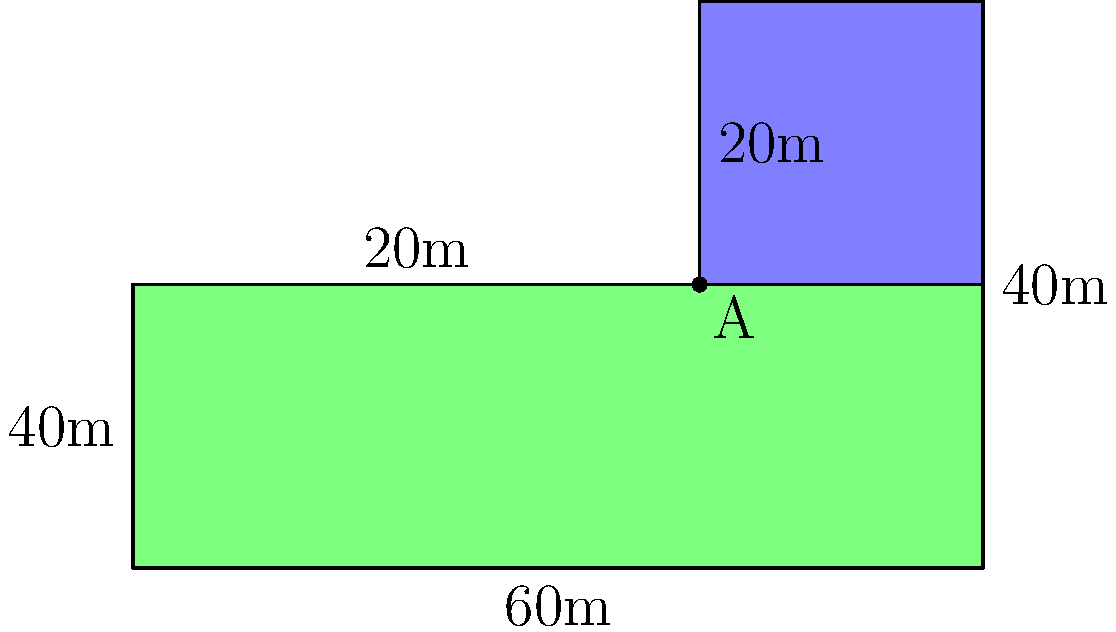A proposed affordable housing complex has an irregular shape as shown in the diagram. The main building (green area) is L-shaped, and there's an additional rectangular community center (blue area) attached to it. Given the dimensions in the diagram, calculate the total area of the complex in square meters. To calculate the total area, we'll break down the complex into simpler shapes and add their areas:

1. L-shaped main building (green area):
   - We can divide this into two rectangles:
     a. Large rectangle: $60\text{ m} \times 20\text{ m} = 1200\text{ m}^2$
     b. Small rectangle: $40\text{ m} \times 20\text{ m} = 800\text{ m}^2$
   - Total area of main building: $1200\text{ m}^2 + 800\text{ m}^2 = 2000\text{ m}^2$

2. Community center (blue area):
   - This is a simple rectangle: $20\text{ m} \times 20\text{ m} = 400\text{ m}^2$

3. Total area of the complex:
   - Sum of all areas: $2000\text{ m}^2 + 400\text{ m}^2 = 2400\text{ m}^2$

Therefore, the total area of the affordable housing complex is $2400\text{ m}^2$.
Answer: $2400\text{ m}^2$ 